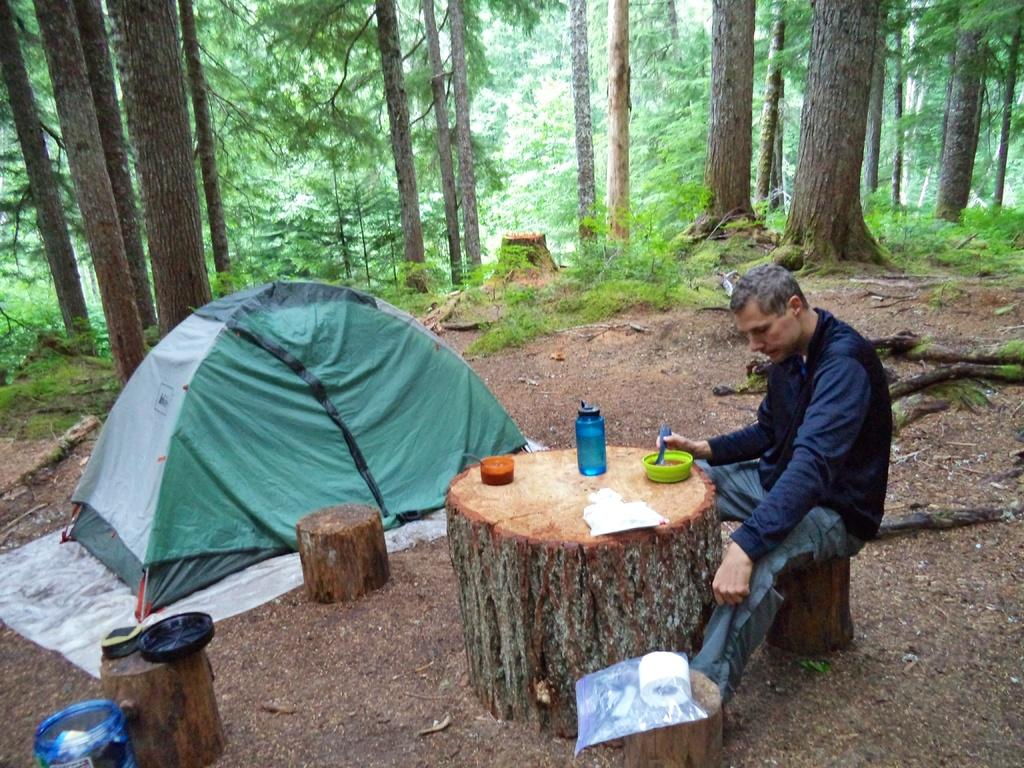What is the person in the image wearing on their upper body? The person is wearing a blue jacket. What type of pants is the person wearing? The person is wearing jeans. What is the person doing in the image? The person is sitting. What is the person having in the image? The person is having a food item. What can be seen in the background of the image? There is a camping tent and trees in the background of the image. What type of wool is being spun by the person in the image? There is no wool or spinning activity present in the image. How many wristwatches is the person wearing in the image? The person is not wearing any wristwatches in the image. 